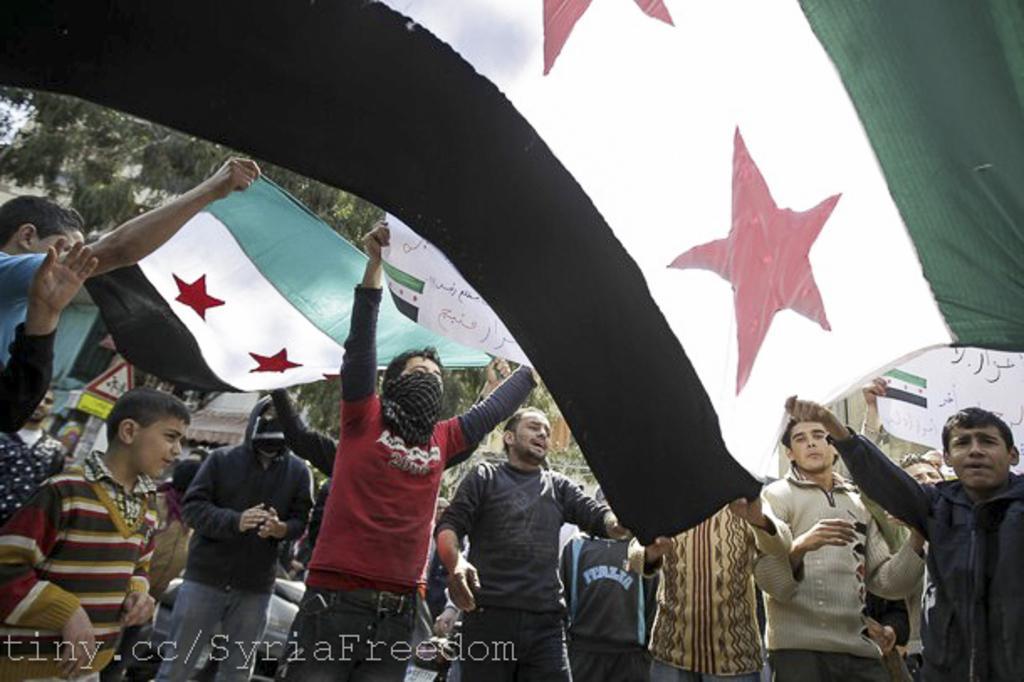Describe this image in one or two sentences. In this image, there are some people standing and they are holding some flags which are in black, white and green color, in the background there are some green color trees. 